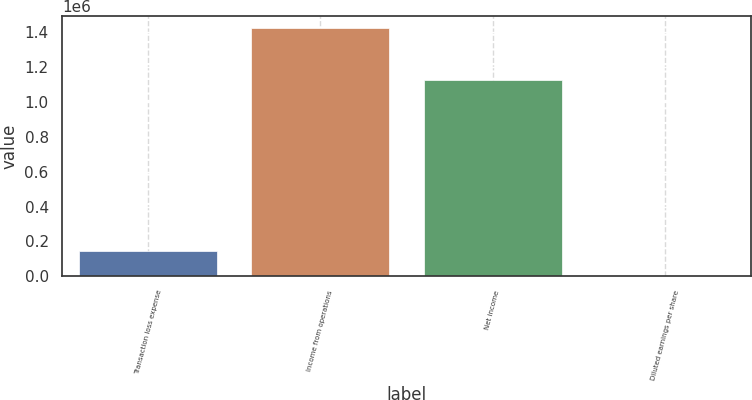<chart> <loc_0><loc_0><loc_500><loc_500><bar_chart><fcel>Transaction loss expense<fcel>Income from operations<fcel>Net income<fcel>Diluted earnings per share<nl><fcel>142296<fcel>1.42296e+06<fcel>1.12564e+06<fcel>0.79<nl></chart> 